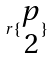Convert formula to latex. <formula><loc_0><loc_0><loc_500><loc_500>r \{ \begin{matrix} p \\ 2 \end{matrix} \}</formula> 